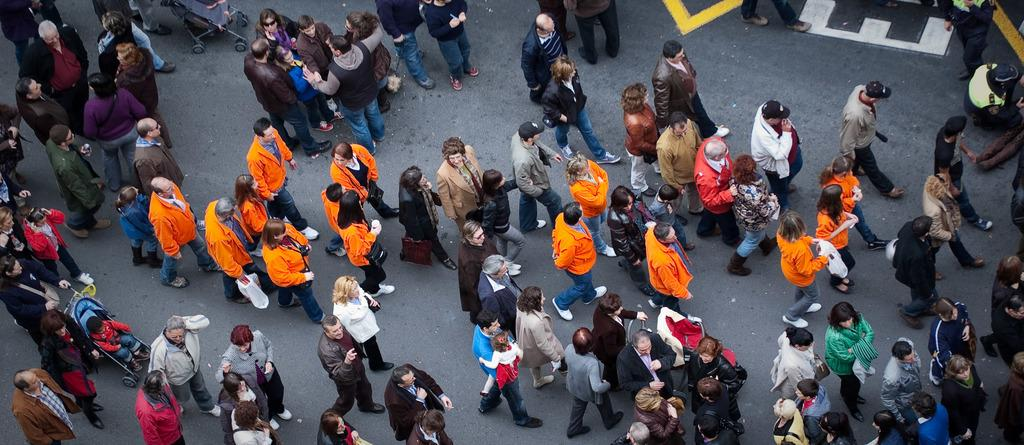What are the people in the image doing? There are people walking and standing in the image. Are any of the standing people engaged in conversation? Yes, some of the standing people are talking. What type of fork can be seen in the drawer in the image? There is no drawer or fork present in the image. 